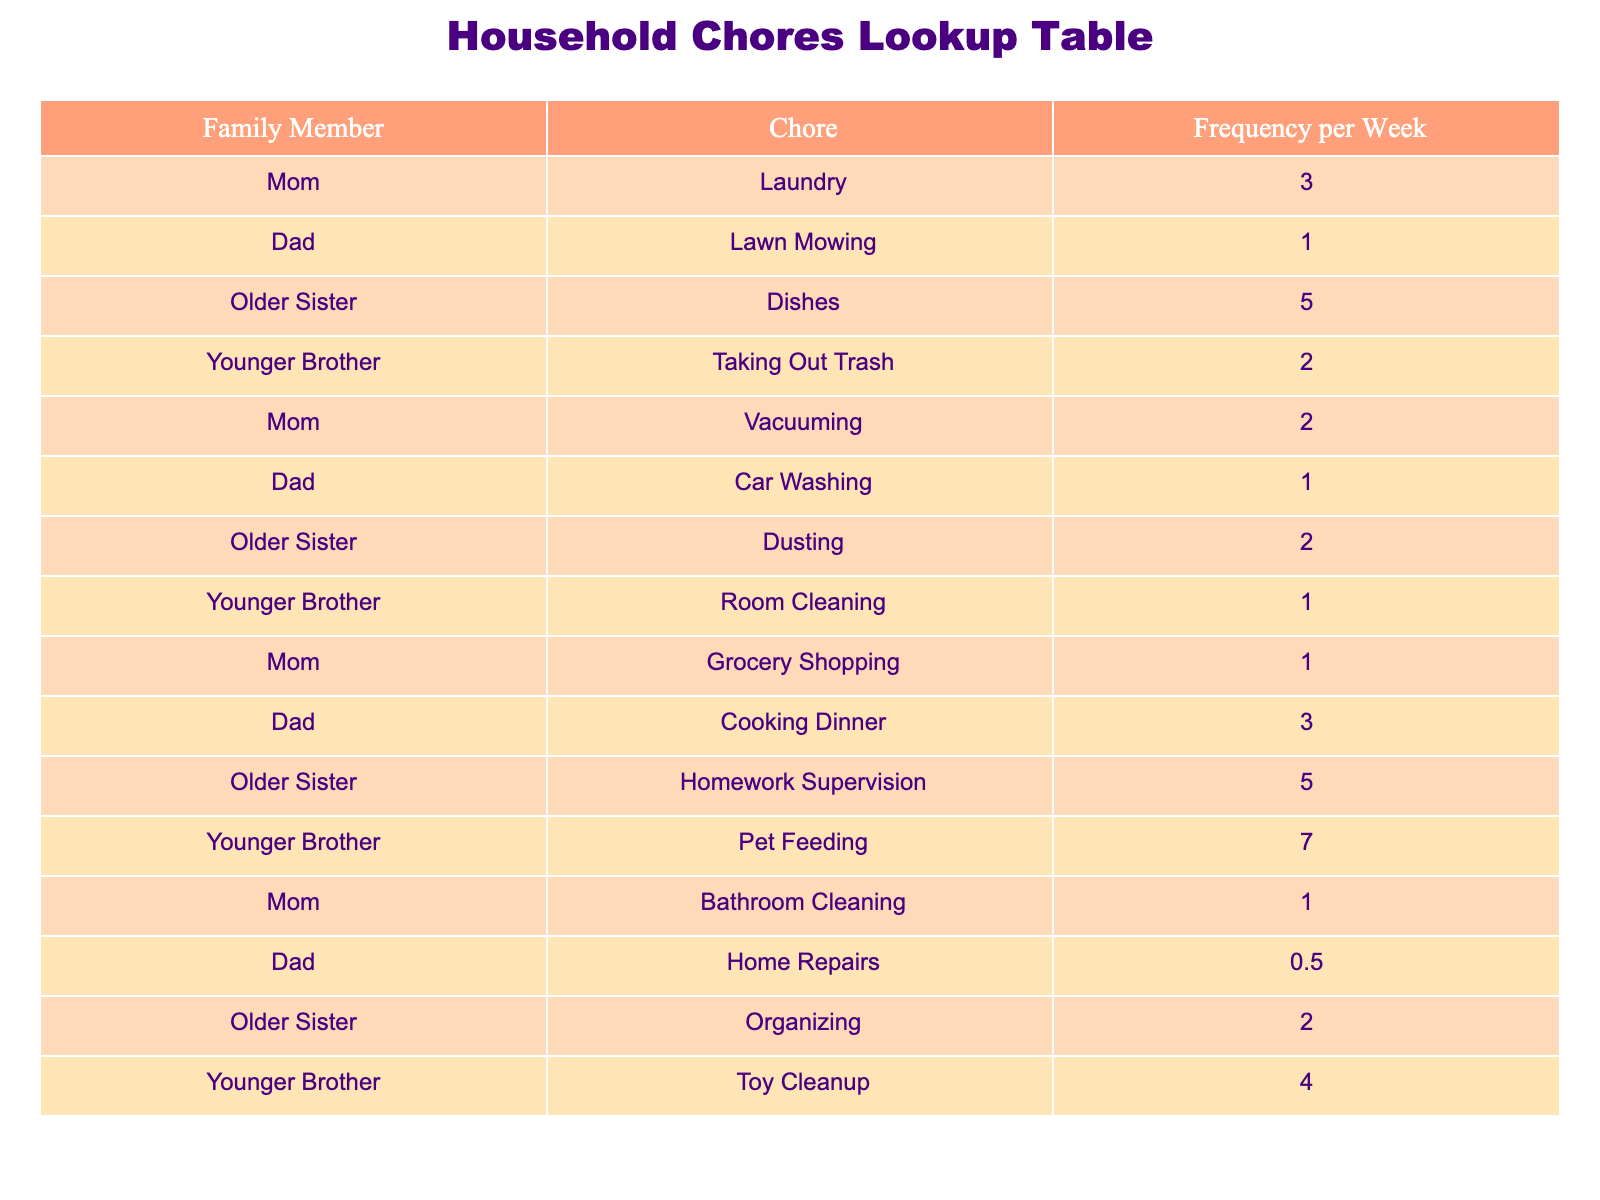What chore does the younger brother do most frequently? The younger brother's most frequently listed chore is pet feeding, which he does 7 times a week.
Answer: Pet feeding How many chores does the older sister perform? The older sister performs a total of 4 distinct chores: dishes, dusting, homework supervision, and organizing.
Answer: 4 Which family member does laundry the most? The table shows that the mom does laundry 3 times a week, which is the highest frequency among family members listed for this chore.
Answer: Mom What is the total frequency of chores performed by the dad? By adding up the frequency of chores done by the dad: lawn mowing (1) + car washing (1) + cooking dinner (3) + home repairs (0.5) = 5.5.
Answer: 5.5 Is there a family member who has no chores listed? Yes, the dad has the chore of home repairs listed with a frequency of 0.5, indicating that it is not a regular activity for him.
Answer: Yes How many total chores does the younger brother do per week? By summing the frequency of the younger brother's chores: taking out trash (2) + room cleaning (1) + pet feeding (7) + toy cleanup (4) = 14.
Answer: 14 Which chore is done most frequently across all family members? If we analyze the completed frequencies, the older sister's dishes and homework supervision both occur 5 times a week, which is the highest frequency job mentioned.
Answer: Dishes and Homework Supervision What is the average frequency of chores done by the family members? To calculate the average, we first find the total frequencies: 3 + 1 + 5 + 2 + 2 + 1 + 3 + 5 + 7 + 1 + 0.5 + 2 + 4 = 32. The total number of entries is 13. Thus, average = 32 / 13 ≈ 2.46.
Answer: Approximately 2.46 How many chores does the mom do in total? The total frequency of chores the mom does is calculated as follows: laundry (3) + vacuuming (2) + grocery shopping (1) + bathroom cleaning (1) = 7.
Answer: 7 